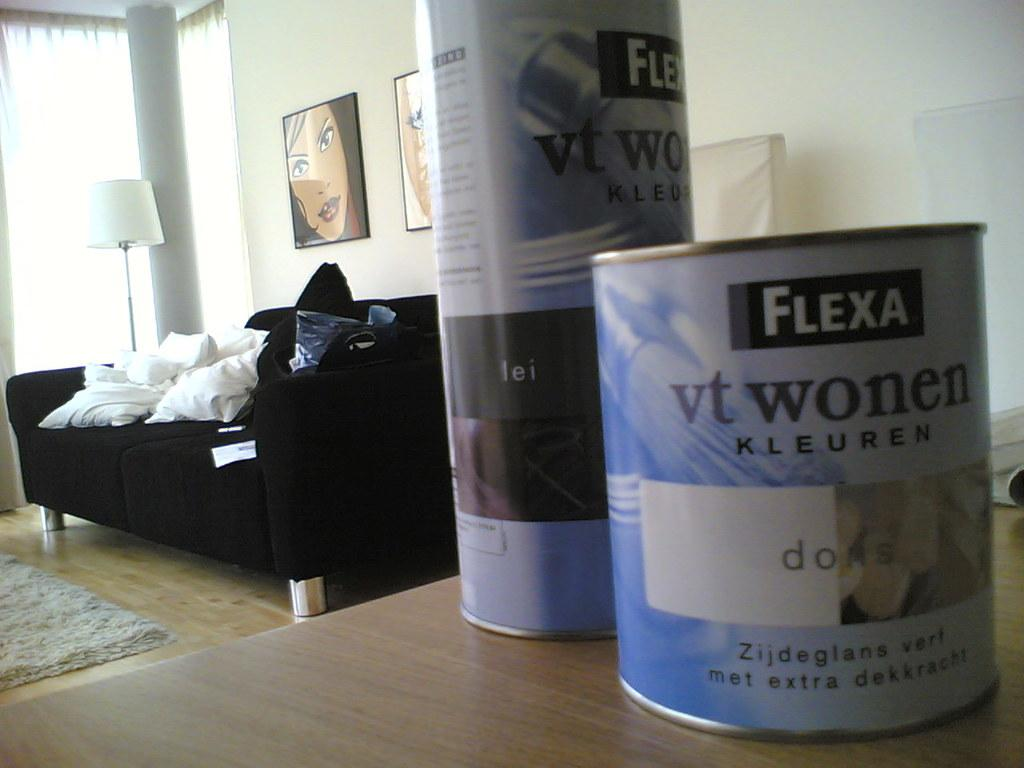Provide a one-sentence caption for the provided image. A few containers of FLEXA vt wonen KLEUREN is on a table with a couch and lamp behind them. 